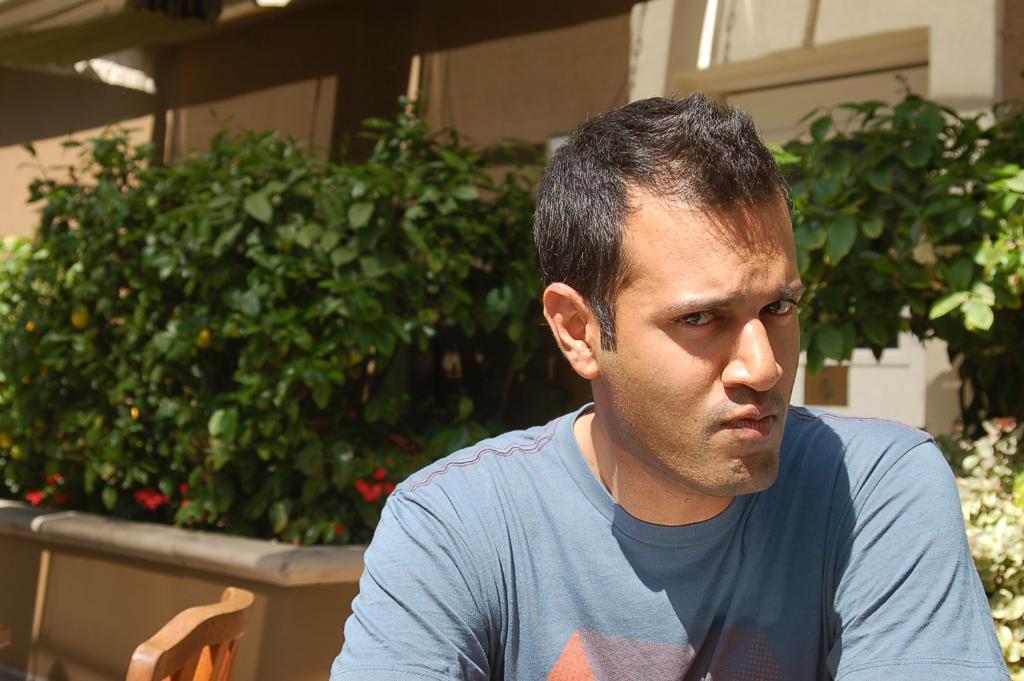In one or two sentences, can you explain what this image depicts? In this image in the front there is a person. In the background there are plants and there is a building. 